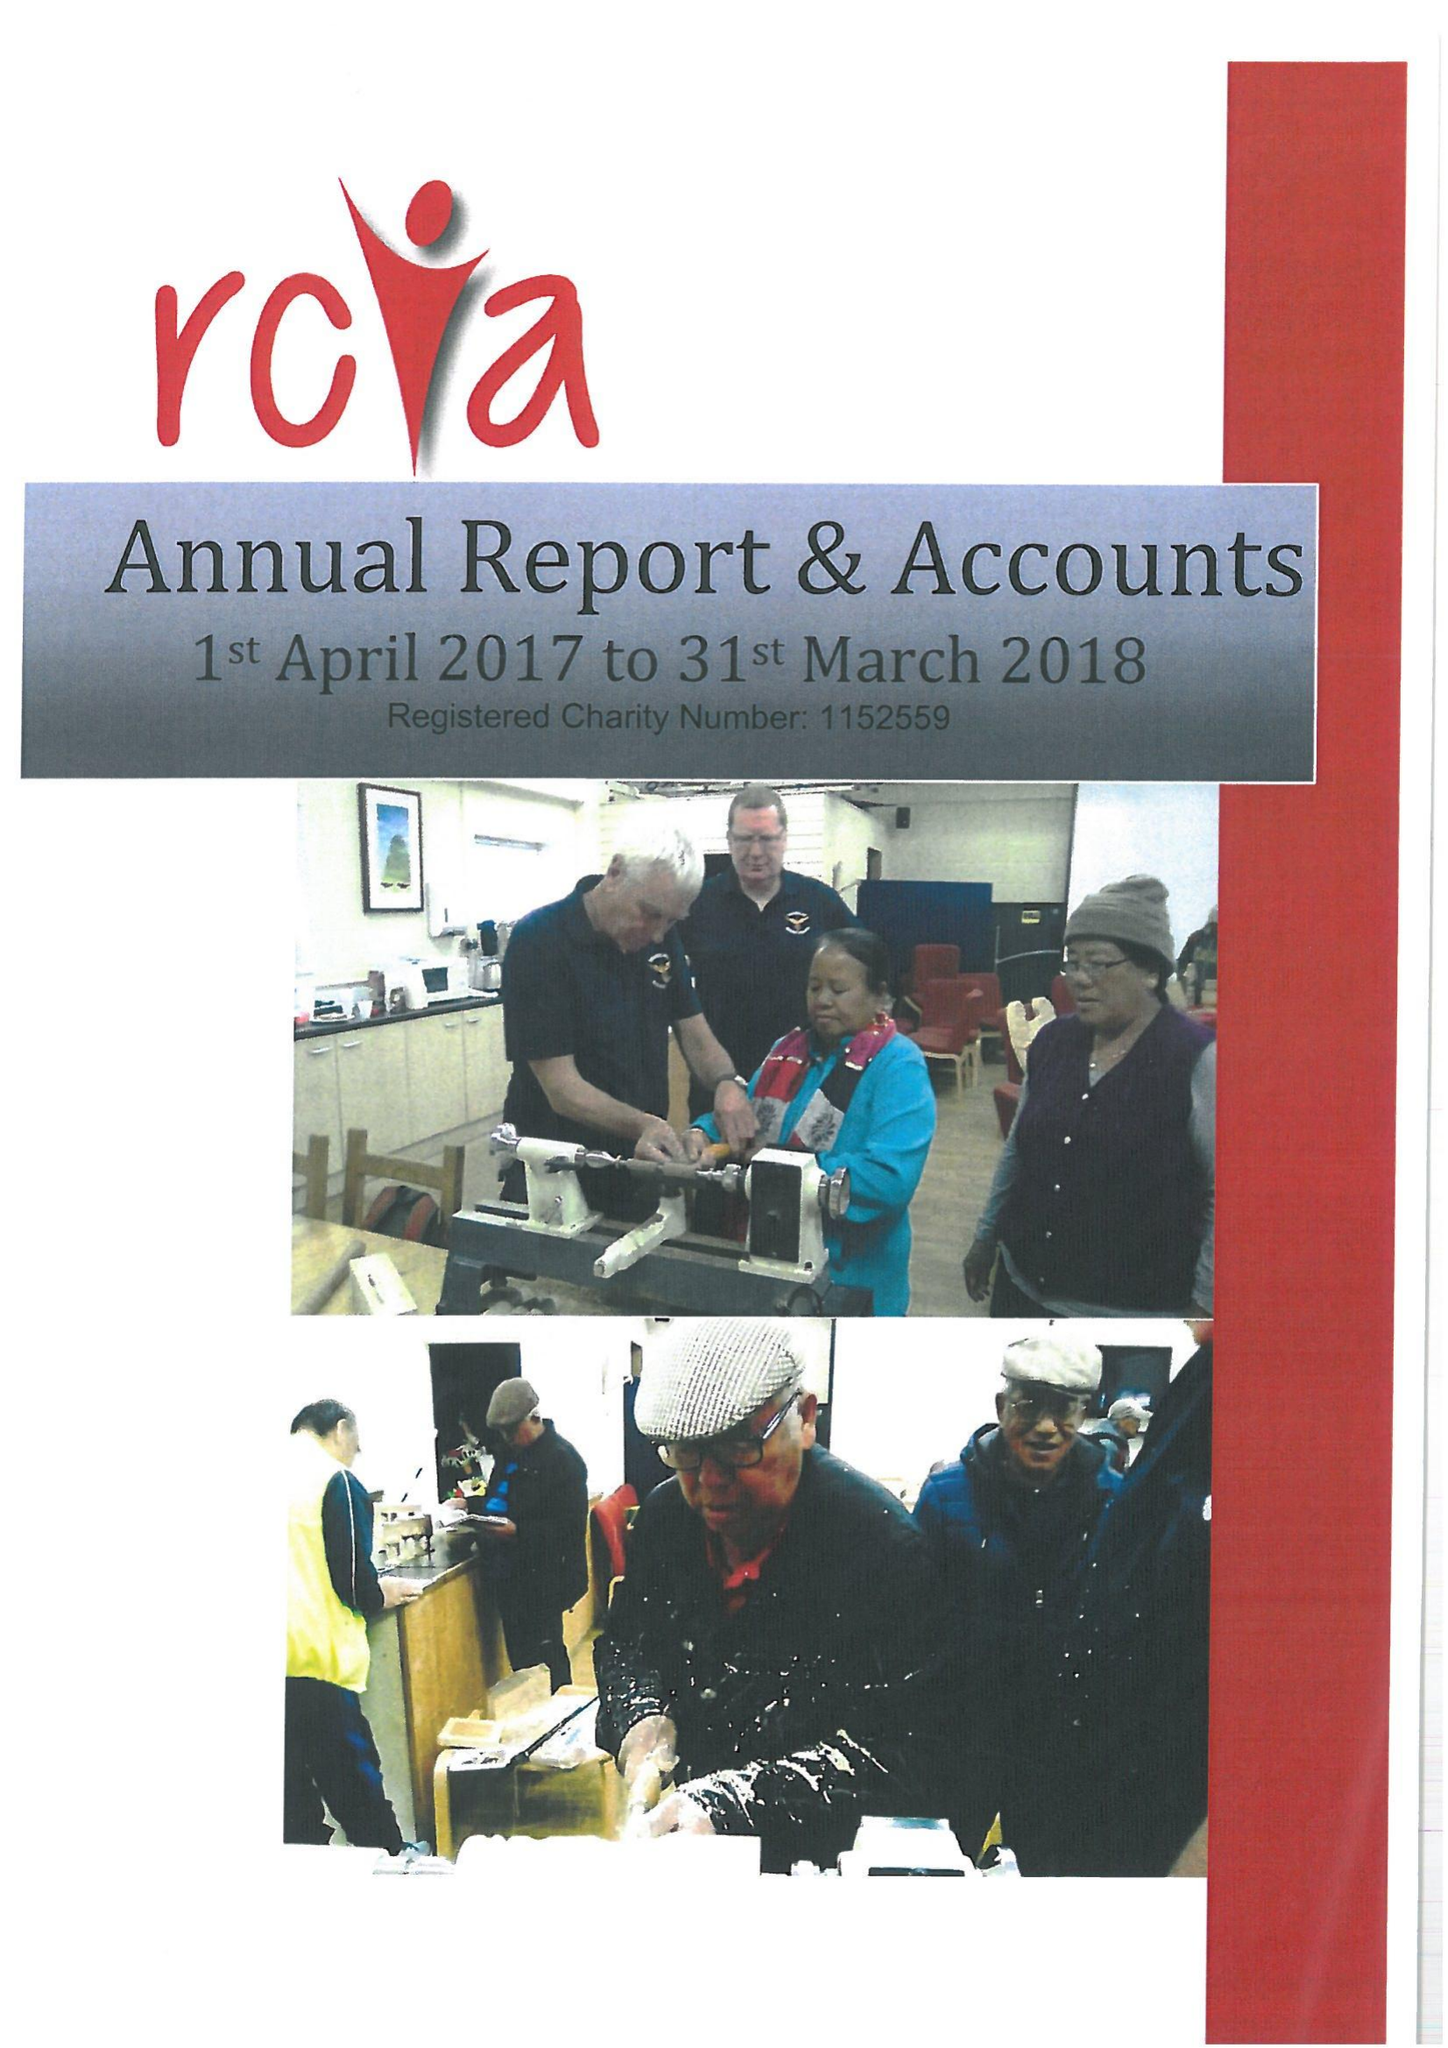What is the value for the address__street_line?
Answer the question using a single word or phrase. SHUTE ROAD 